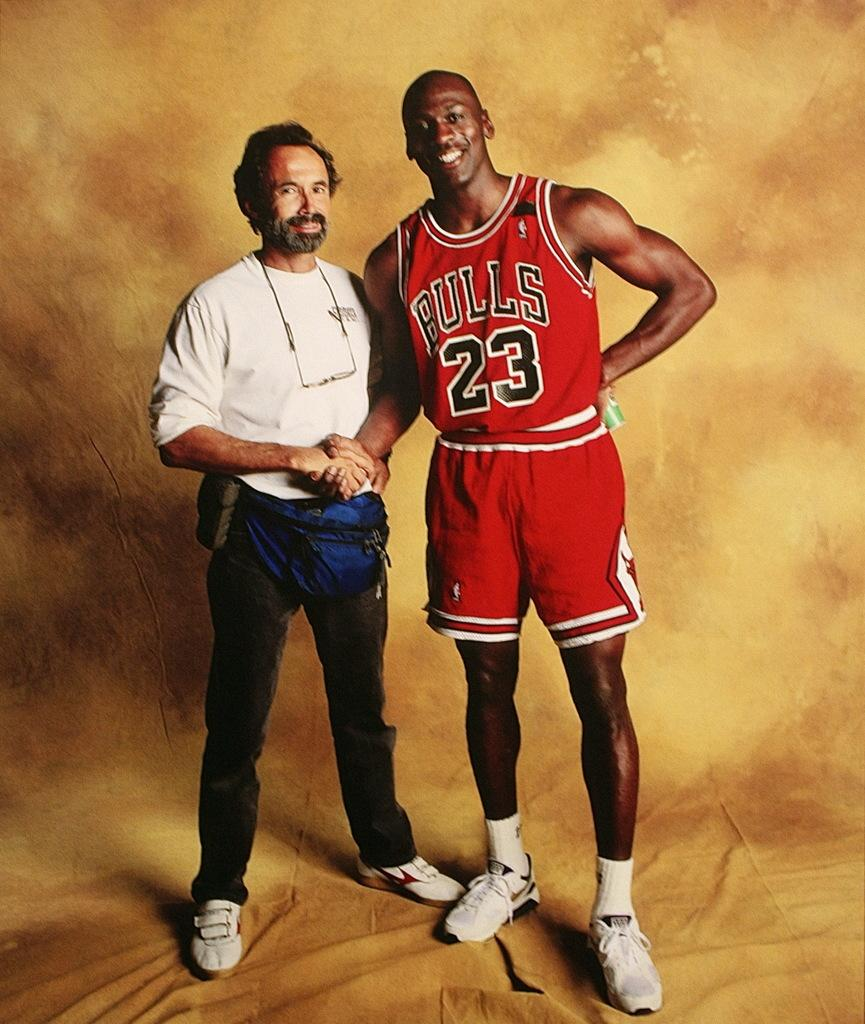<image>
Give a short and clear explanation of the subsequent image. A man wearing a Bulls basketball jersey is shaking hands with another man. 